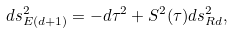<formula> <loc_0><loc_0><loc_500><loc_500>d s _ { E ( d + 1 ) } ^ { 2 } = - d \tau ^ { 2 } + S ^ { 2 } ( \tau ) d s _ { R d } ^ { 2 } ,</formula> 